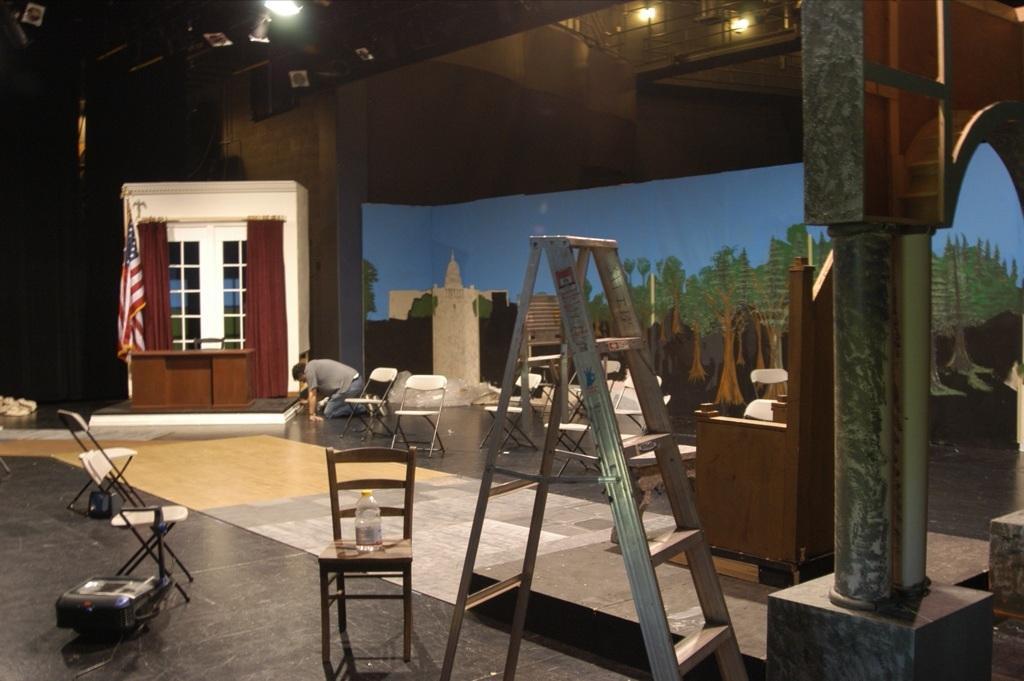Can you describe this image briefly? In this image we can see a ladder, wooden chair, a bottle, few more chairs, pillar, a person hear, a flag, curtains, lights on the ceiling and a wall with poster in the background. 